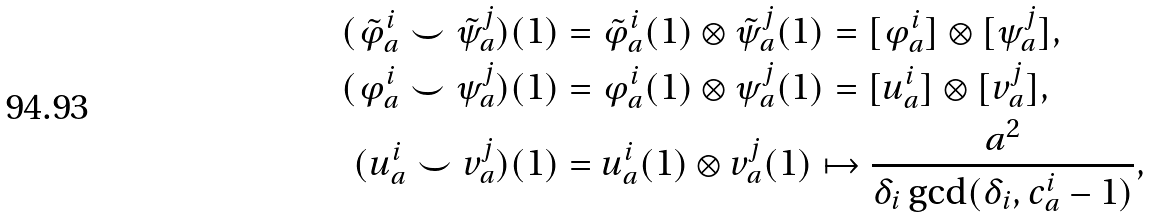<formula> <loc_0><loc_0><loc_500><loc_500>( \tilde { \varphi } _ { a } ^ { i } \smile \tilde { \psi } _ { a } ^ { j } ) ( 1 ) & = \tilde { \varphi } _ { a } ^ { i } ( 1 ) \otimes \tilde { \psi } _ { a } ^ { j } ( 1 ) = [ \varphi _ { a } ^ { i } ] \otimes [ \psi _ { a } ^ { j } ] , \\ ( \varphi _ { a } ^ { i } \smile \psi _ { a } ^ { j } ) ( 1 ) & = \varphi _ { a } ^ { i } ( 1 ) \otimes \psi _ { a } ^ { j } ( 1 ) = [ u _ { a } ^ { i } ] \otimes [ v _ { a } ^ { j } ] , \\ ( u _ { a } ^ { i } \smile v _ { a } ^ { j } ) ( 1 ) & = u _ { a } ^ { i } ( 1 ) \otimes v _ { a } ^ { j } ( 1 ) \mapsto \frac { a ^ { 2 } } { \delta _ { i } \gcd ( \delta _ { i } , c _ { a } ^ { i } - 1 ) } ,</formula> 